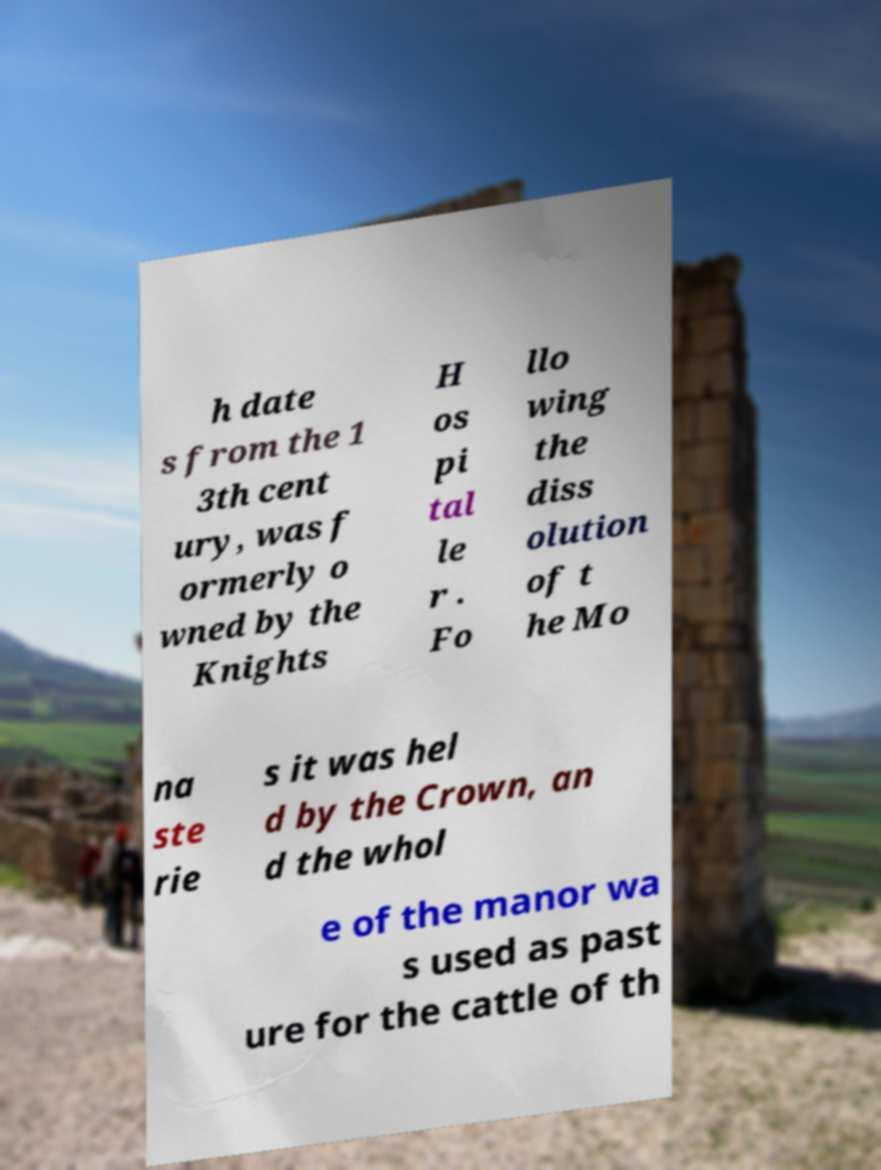Please identify and transcribe the text found in this image. h date s from the 1 3th cent ury, was f ormerly o wned by the Knights H os pi tal le r . Fo llo wing the diss olution of t he Mo na ste rie s it was hel d by the Crown, an d the whol e of the manor wa s used as past ure for the cattle of th 